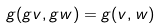Convert formula to latex. <formula><loc_0><loc_0><loc_500><loc_500>g ( g v , g w ) = g ( v , w )</formula> 